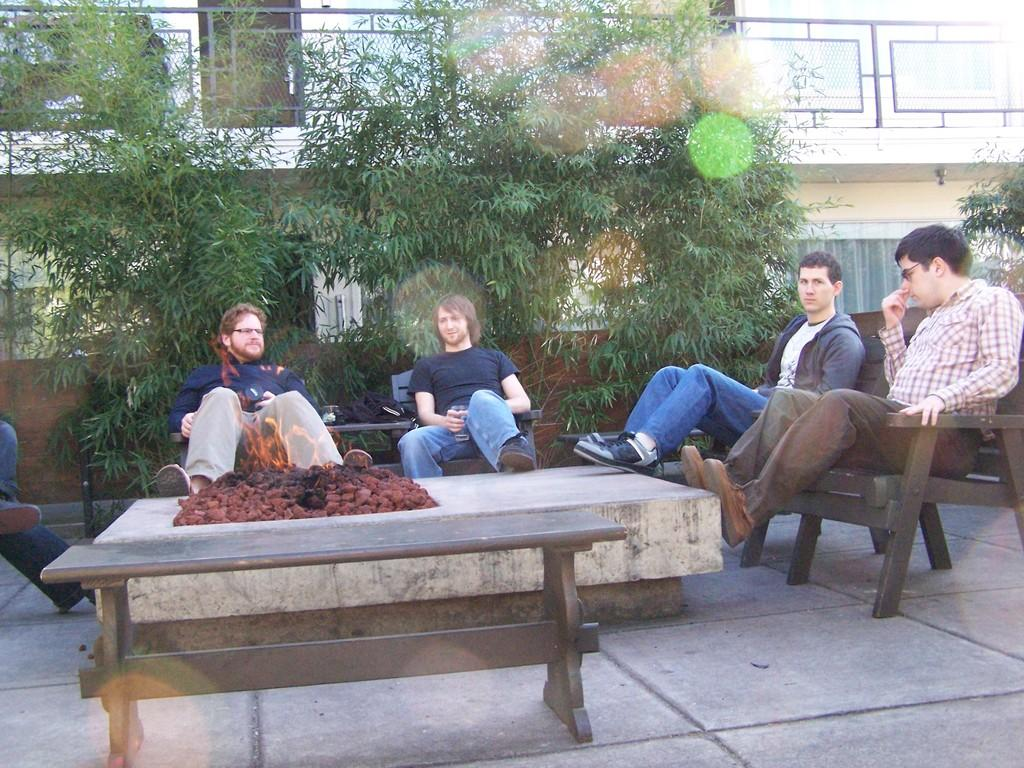How many people are in the image? There are four men in the image. What are the men doing in the image? The men are sitting on chairs and a bench. What is located at the bottom of the image? There is a table in the bottom of the image. What can be seen in the background of the image? There are trees and a building in the background of the image. What type of verse can be heard being recited by the crow in the image? There is no crow present in the image, and therefore no verse can be heard. Which man in the image has the largest ear? The image does not provide enough detail to determine the size of the men's ears, so it cannot be answered definitively. 